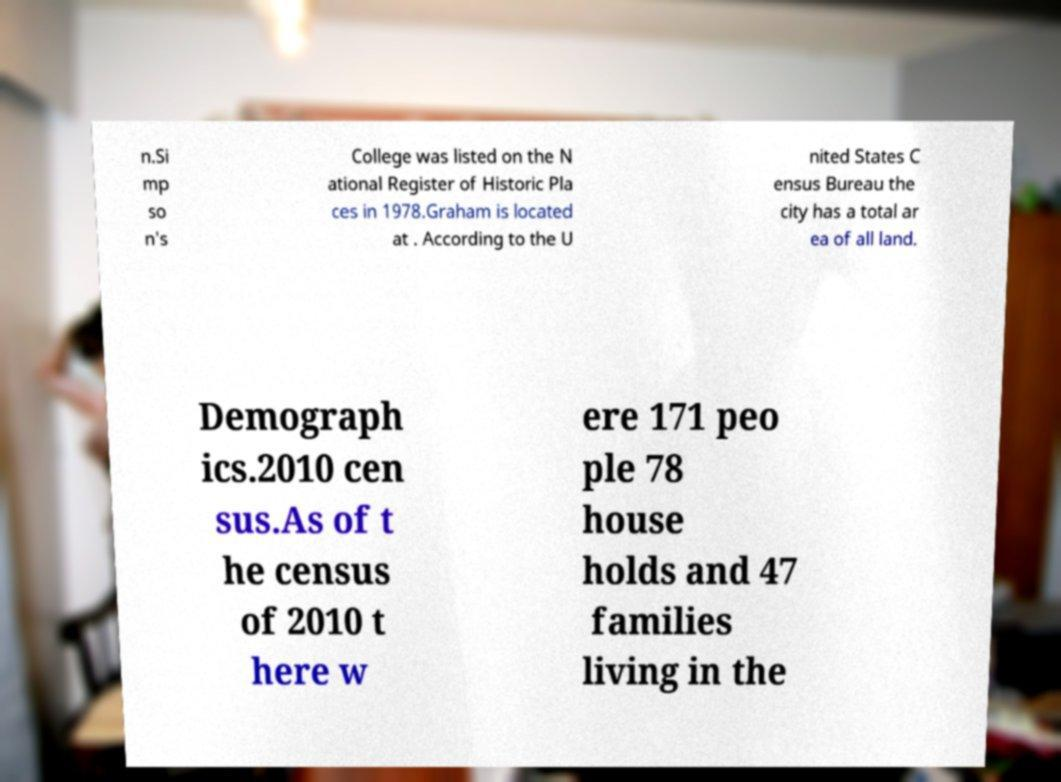What messages or text are displayed in this image? I need them in a readable, typed format. n.Si mp so n's College was listed on the N ational Register of Historic Pla ces in 1978.Graham is located at . According to the U nited States C ensus Bureau the city has a total ar ea of all land. Demograph ics.2010 cen sus.As of t he census of 2010 t here w ere 171 peo ple 78 house holds and 47 families living in the 